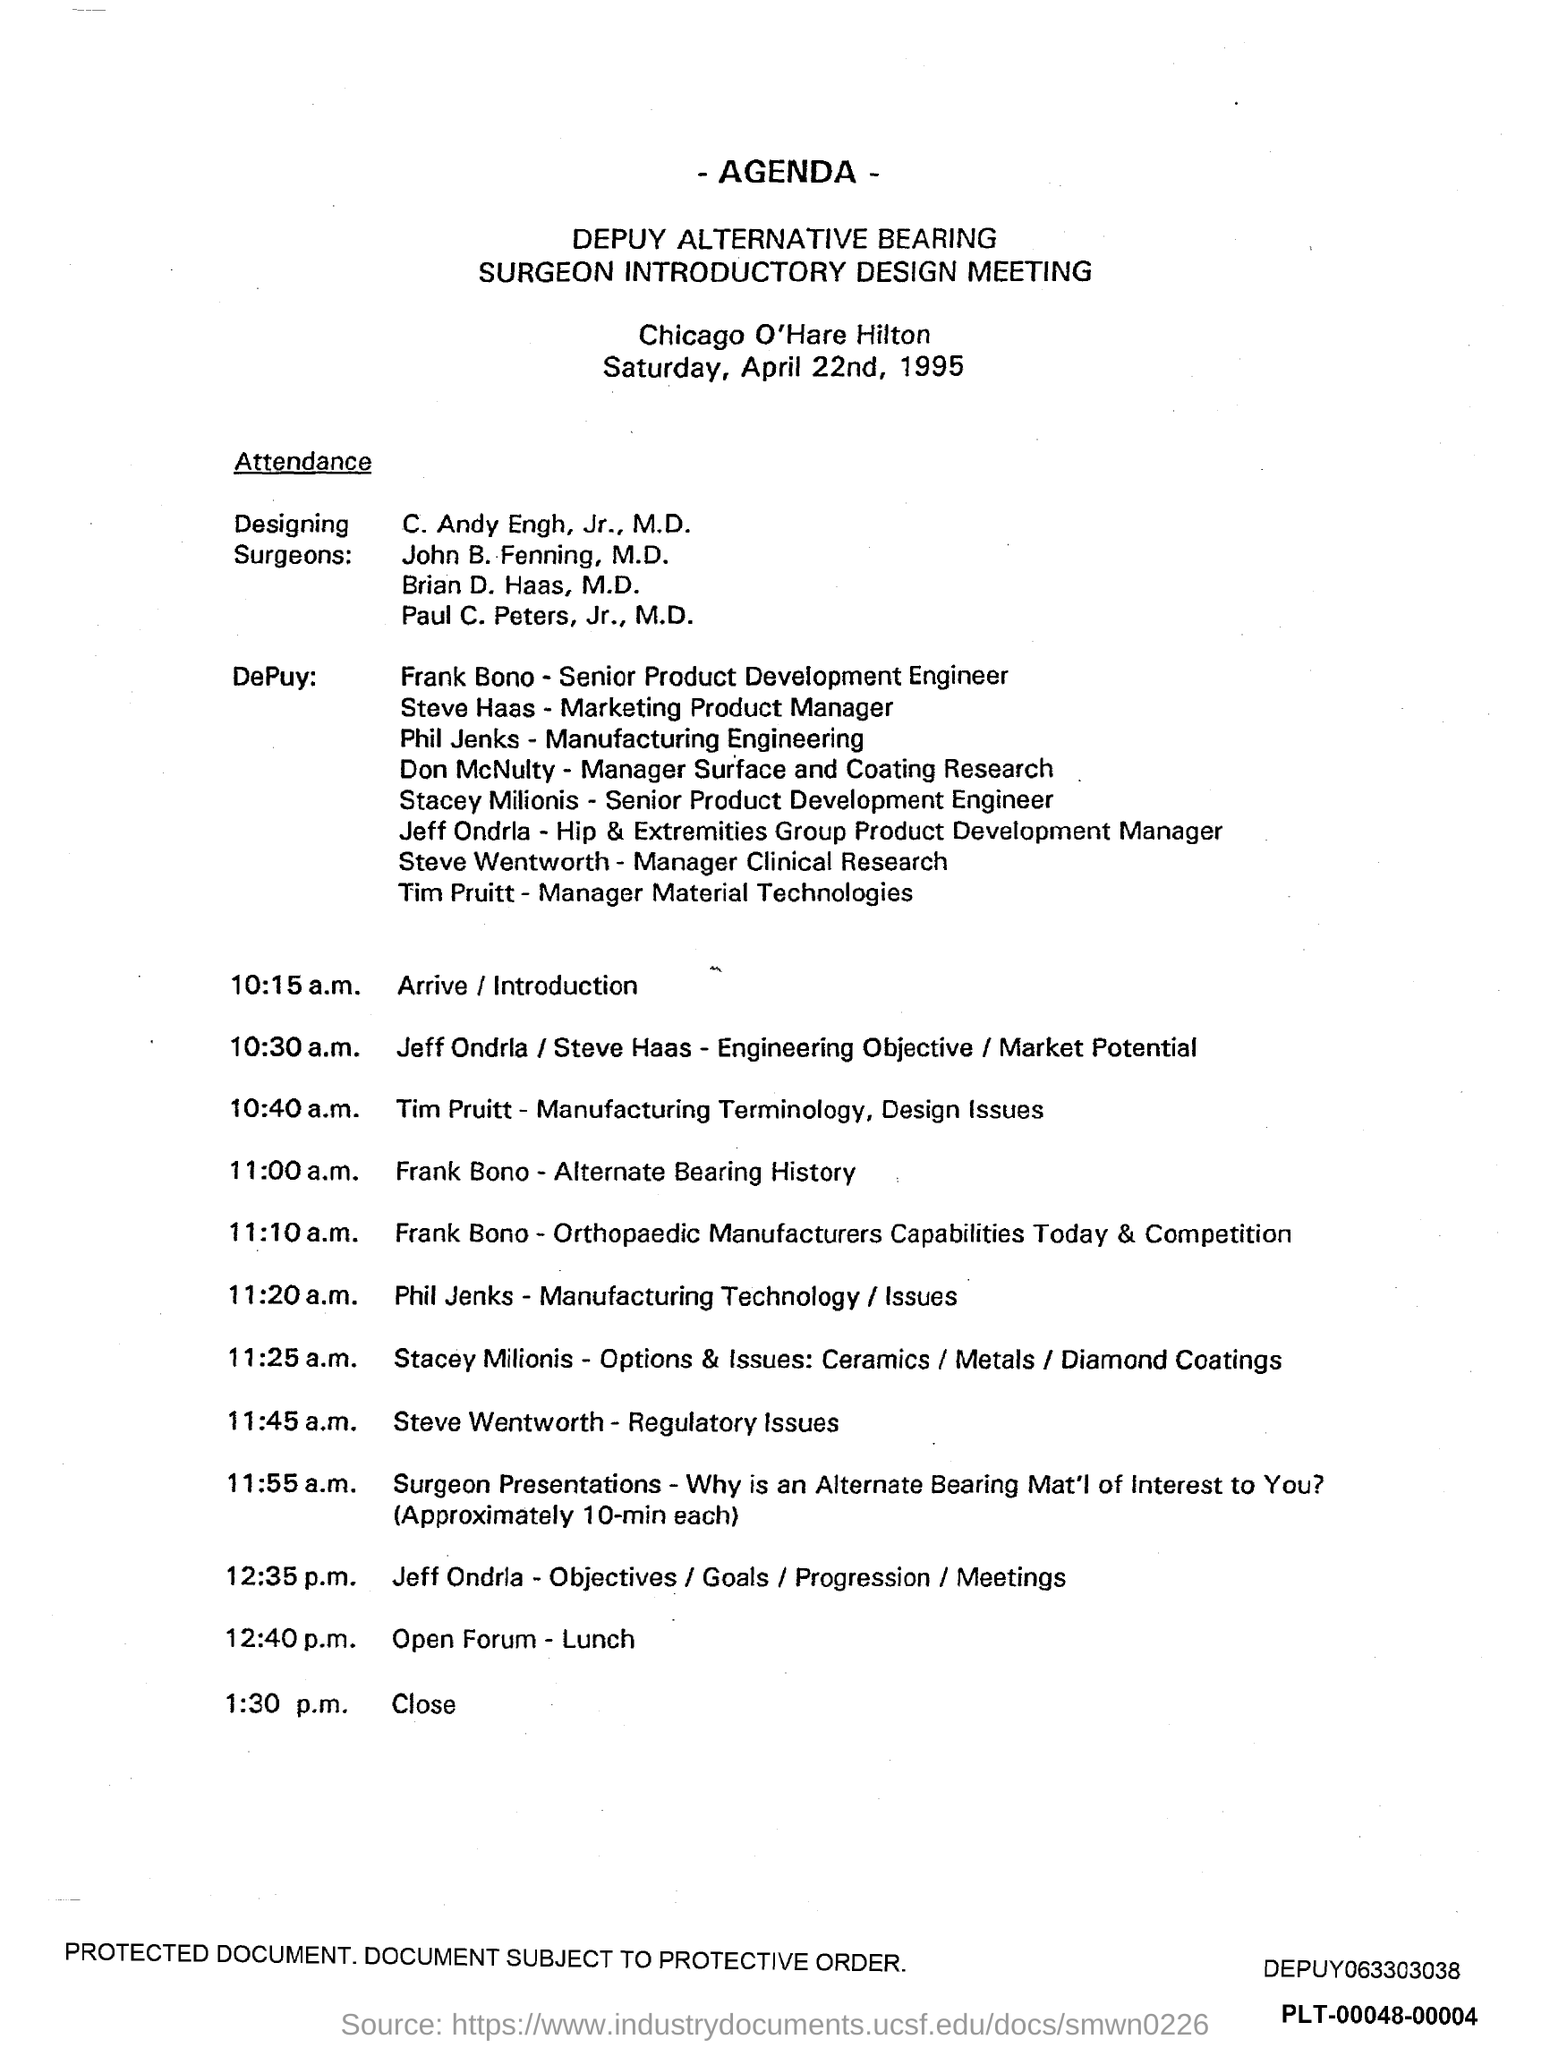what is the time scheduled for Close ? The scheduled time for the 'Close' of the DEPUY ALTERNATIVE BEARING SURGEON INTRODUCTORY DESIGN MEETING is at 1:30 p.m., as per the agenda for the event held at Chicago O’Hare Hilton on Saturday, April 22nd, 1995. 